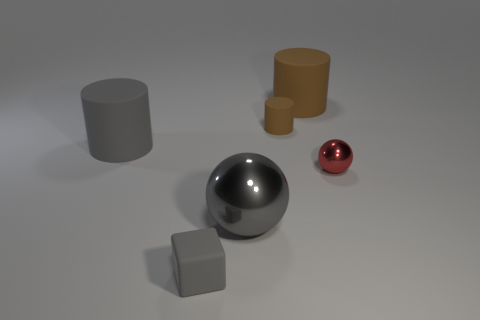There is a red metallic ball; are there any gray shiny objects in front of it?
Give a very brief answer. Yes. What size is the other ball that is made of the same material as the tiny red ball?
Keep it short and to the point. Large. How many large brown matte objects have the same shape as the red thing?
Offer a very short reply. 0. Do the tiny gray object and the large cylinder that is right of the gray matte cylinder have the same material?
Ensure brevity in your answer.  Yes. Are there more metallic things that are left of the tiny brown matte thing than tiny purple matte objects?
Your answer should be very brief. Yes. What shape is the shiny object that is the same color as the small cube?
Make the answer very short. Sphere. Is there a gray block that has the same material as the small brown thing?
Provide a succinct answer. Yes. Does the large object that is right of the large gray ball have the same material as the tiny thing in front of the tiny red metallic thing?
Provide a succinct answer. Yes. Is the number of large brown matte things that are in front of the gray ball the same as the number of cylinders to the right of the gray matte cylinder?
Keep it short and to the point. No. There is a cube that is the same size as the red metallic ball; what color is it?
Offer a terse response. Gray. 